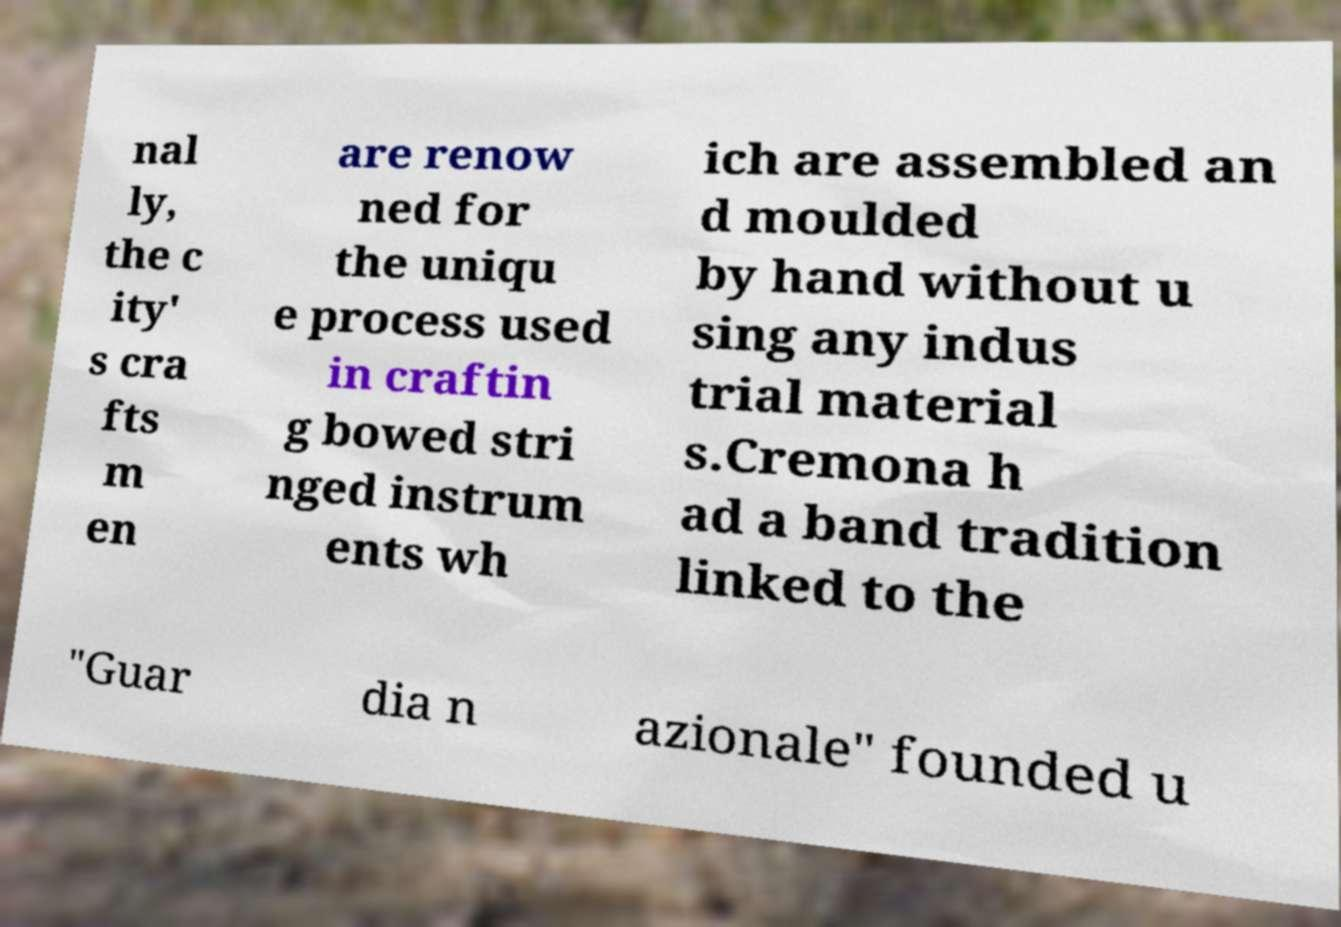Please identify and transcribe the text found in this image. nal ly, the c ity' s cra fts m en are renow ned for the uniqu e process used in craftin g bowed stri nged instrum ents wh ich are assembled an d moulded by hand without u sing any indus trial material s.Cremona h ad a band tradition linked to the "Guar dia n azionale" founded u 